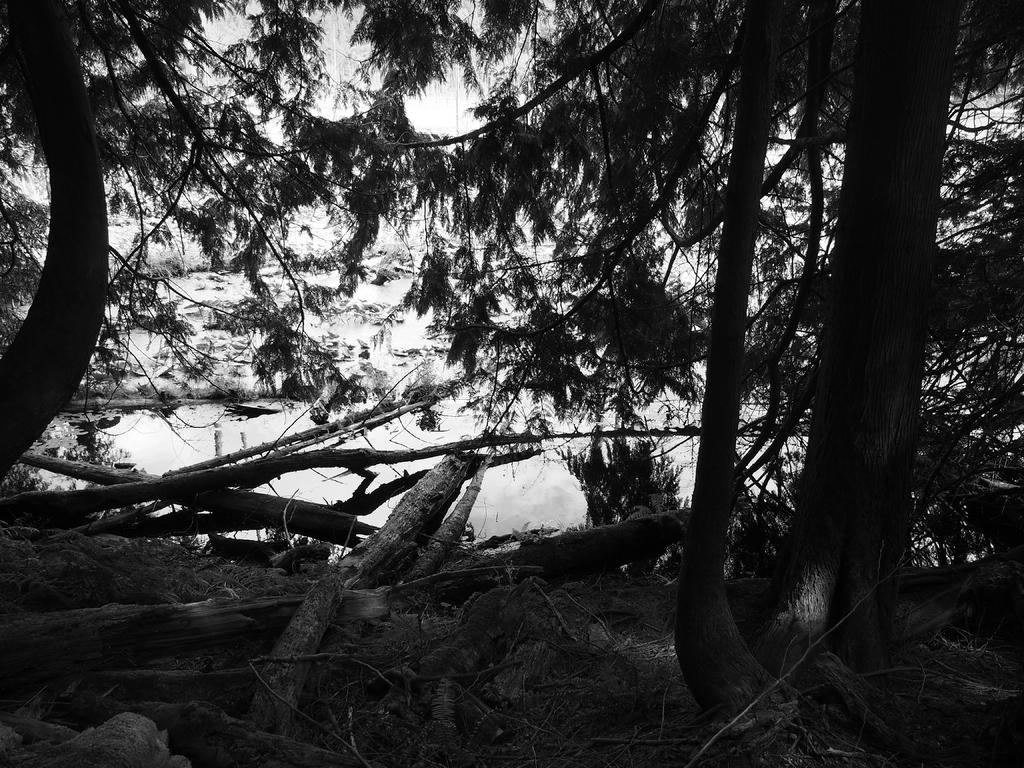Please provide a concise description of this image. This is a black and white image. In this image there are trees. At the bottom there are logs. In the background there is water and sky. 